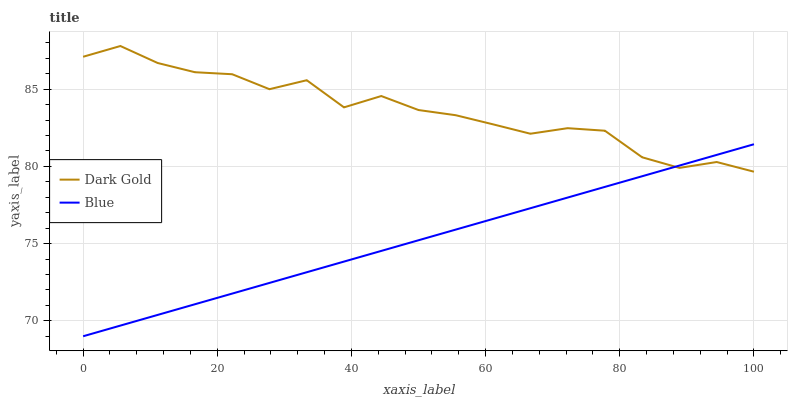Does Blue have the minimum area under the curve?
Answer yes or no. Yes. Does Dark Gold have the maximum area under the curve?
Answer yes or no. Yes. Does Dark Gold have the minimum area under the curve?
Answer yes or no. No. Is Blue the smoothest?
Answer yes or no. Yes. Is Dark Gold the roughest?
Answer yes or no. Yes. Is Dark Gold the smoothest?
Answer yes or no. No. Does Blue have the lowest value?
Answer yes or no. Yes. Does Dark Gold have the lowest value?
Answer yes or no. No. Does Dark Gold have the highest value?
Answer yes or no. Yes. Does Blue intersect Dark Gold?
Answer yes or no. Yes. Is Blue less than Dark Gold?
Answer yes or no. No. Is Blue greater than Dark Gold?
Answer yes or no. No. 